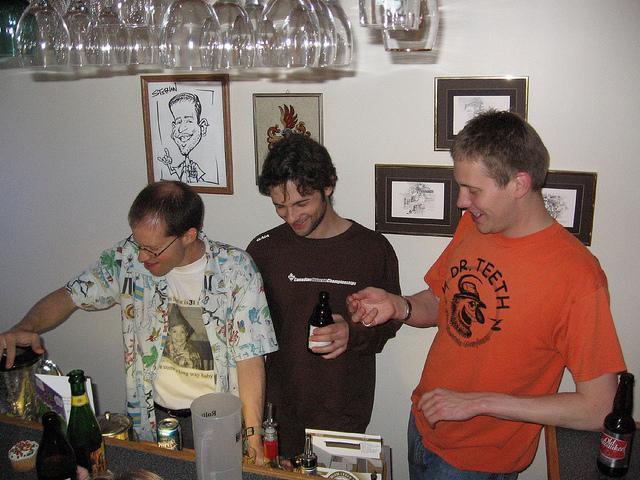How many people are there?
Give a very brief answer. 3. How many wine glasses are there?
Give a very brief answer. 7. How many bottles can be seen?
Give a very brief answer. 3. How many chairs or sofas have a red pillow?
Give a very brief answer. 0. 